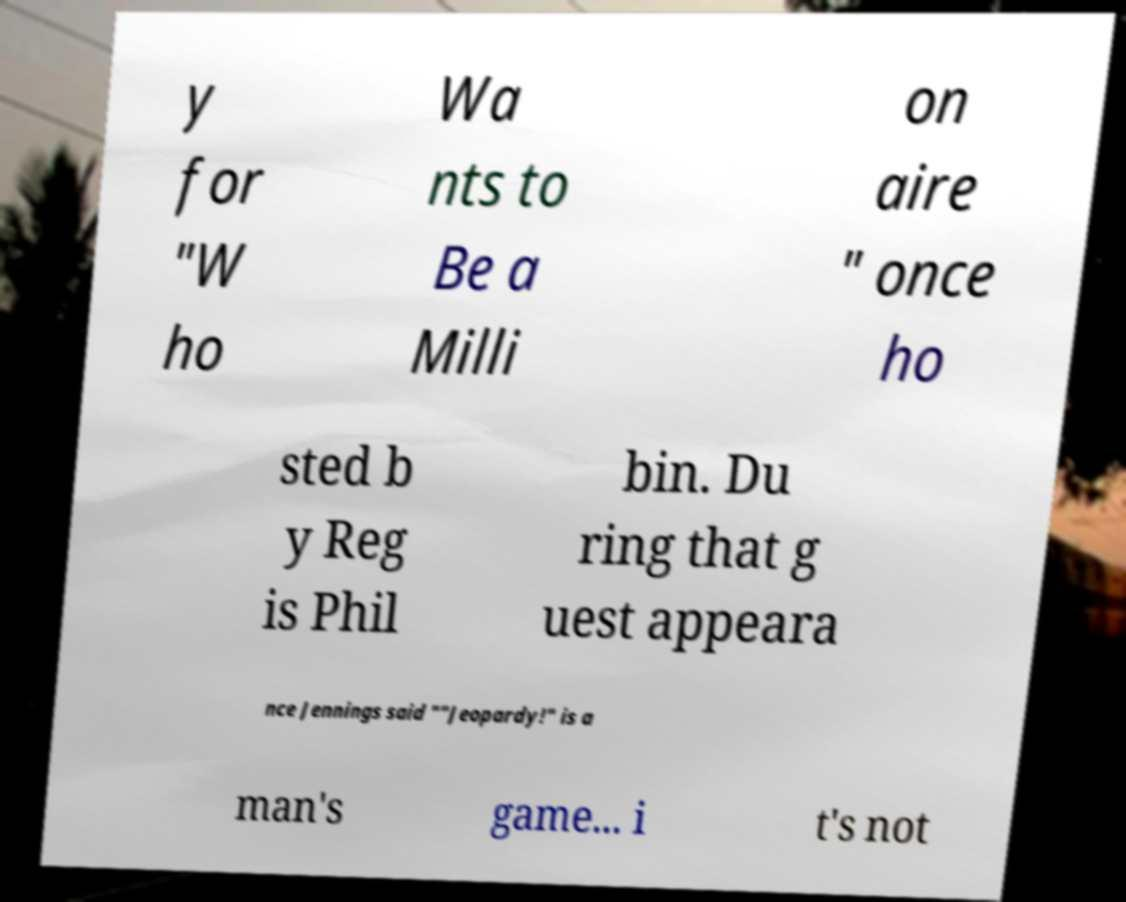Could you extract and type out the text from this image? y for "W ho Wa nts to Be a Milli on aire " once ho sted b y Reg is Phil bin. Du ring that g uest appeara nce Jennings said ""Jeopardy!" is a man's game... i t's not 